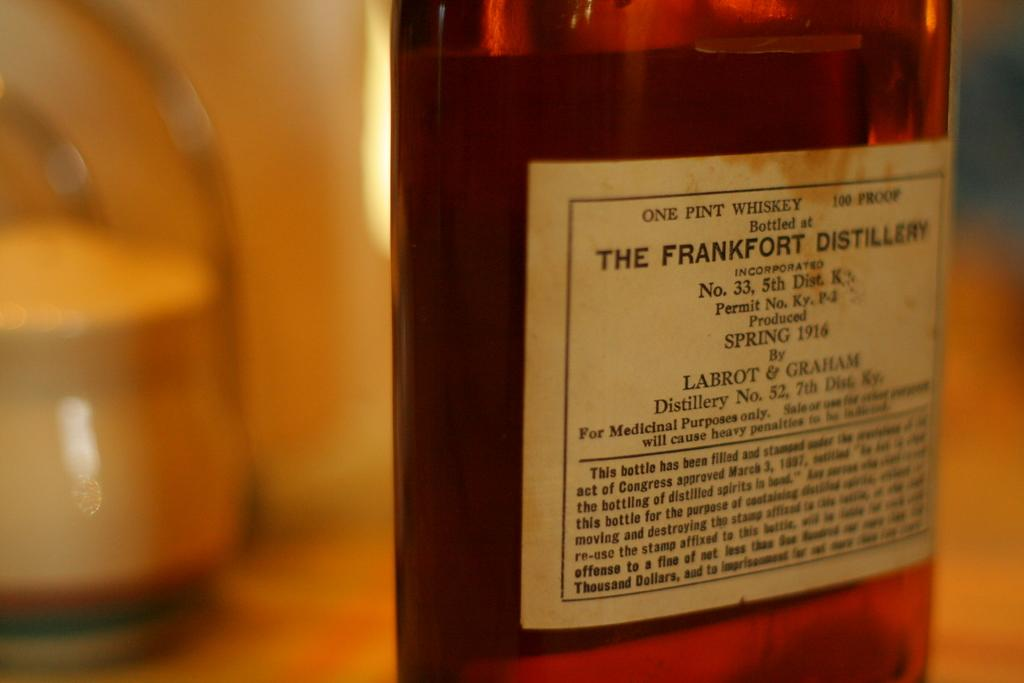<image>
Summarize the visual content of the image. One pint of whiskey bottled at The Frankfort Distillery is 100 proof. 